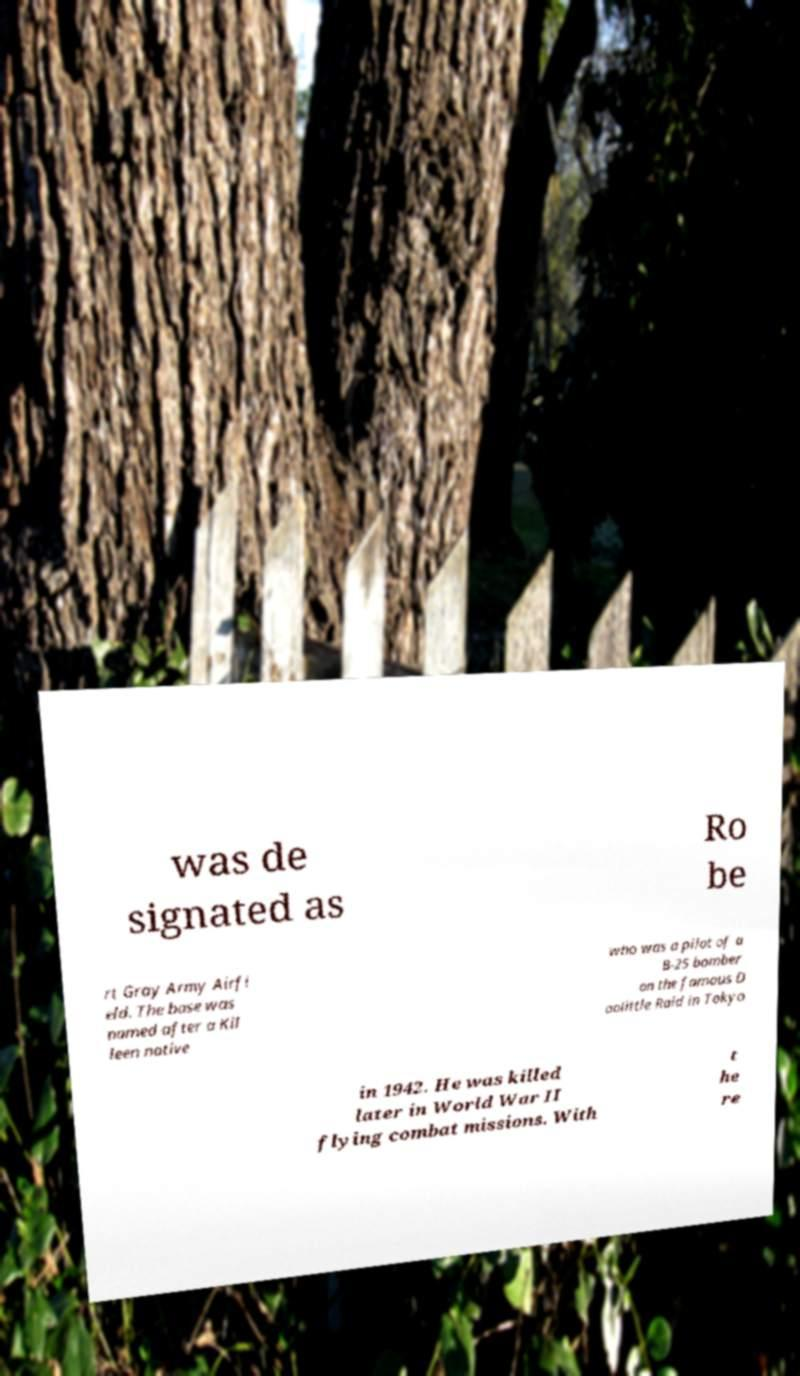I need the written content from this picture converted into text. Can you do that? was de signated as Ro be rt Gray Army Airfi eld. The base was named after a Kil leen native who was a pilot of a B-25 bomber on the famous D oolittle Raid in Tokyo in 1942. He was killed later in World War II flying combat missions. With t he re 